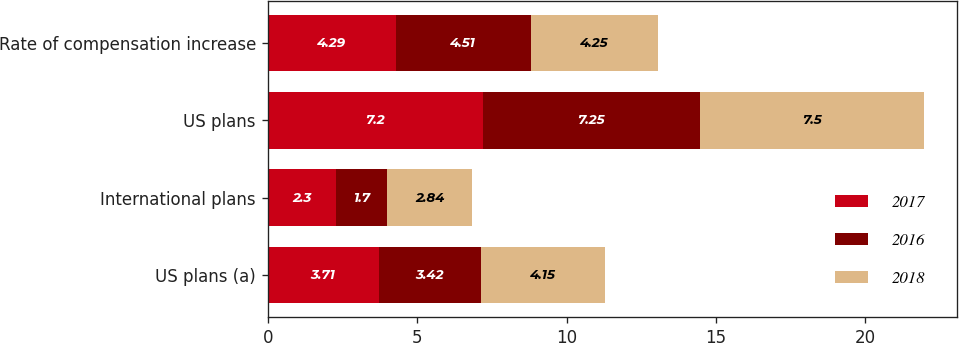<chart> <loc_0><loc_0><loc_500><loc_500><stacked_bar_chart><ecel><fcel>US plans (a)<fcel>International plans<fcel>US plans<fcel>Rate of compensation increase<nl><fcel>2017<fcel>3.71<fcel>2.3<fcel>7.2<fcel>4.29<nl><fcel>2016<fcel>3.42<fcel>1.7<fcel>7.25<fcel>4.51<nl><fcel>2018<fcel>4.15<fcel>2.84<fcel>7.5<fcel>4.25<nl></chart> 